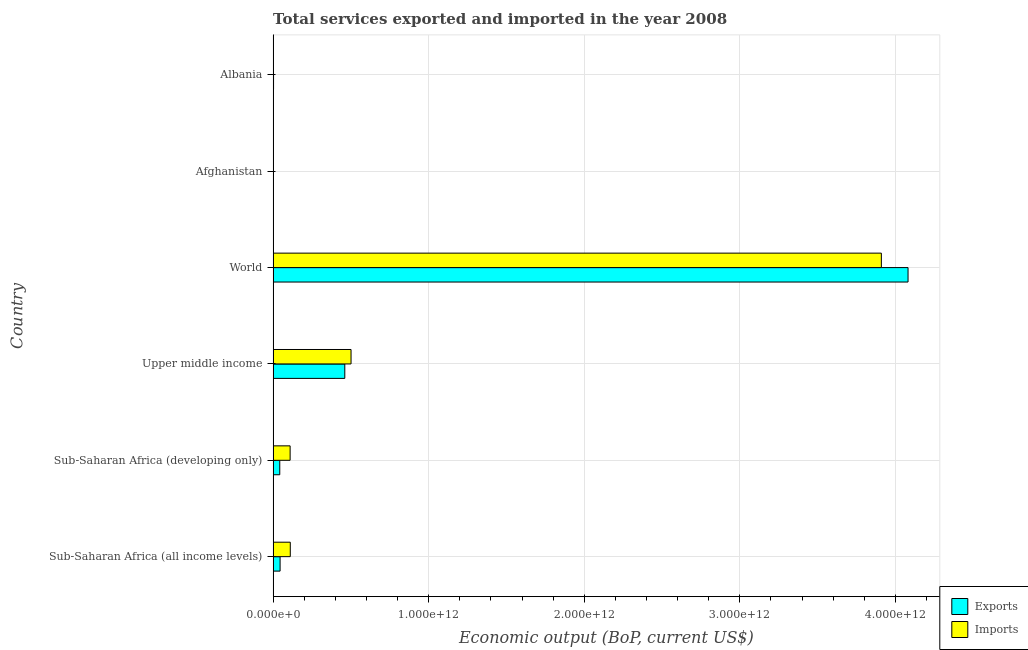Are the number of bars per tick equal to the number of legend labels?
Give a very brief answer. Yes. How many bars are there on the 6th tick from the top?
Provide a succinct answer. 2. In how many cases, is the number of bars for a given country not equal to the number of legend labels?
Provide a succinct answer. 0. What is the amount of service imports in World?
Offer a very short reply. 3.91e+12. Across all countries, what is the maximum amount of service imports?
Ensure brevity in your answer.  3.91e+12. Across all countries, what is the minimum amount of service imports?
Your response must be concise. 5.71e+08. In which country was the amount of service imports minimum?
Provide a succinct answer. Afghanistan. What is the total amount of service exports in the graph?
Your answer should be compact. 4.63e+12. What is the difference between the amount of service exports in Afghanistan and that in Sub-Saharan Africa (developing only)?
Your answer should be very brief. -4.15e+1. What is the difference between the amount of service exports in World and the amount of service imports in Albania?
Your response must be concise. 4.08e+12. What is the average amount of service imports per country?
Your answer should be very brief. 7.72e+11. What is the difference between the amount of service imports and amount of service exports in Upper middle income?
Your response must be concise. 4.02e+1. In how many countries, is the amount of service imports greater than 3200000000000 US$?
Offer a terse response. 1. What is the ratio of the amount of service imports in Sub-Saharan Africa (developing only) to that in Upper middle income?
Your answer should be very brief. 0.22. Is the amount of service imports in Albania less than that in Sub-Saharan Africa (developing only)?
Make the answer very short. Yes. What is the difference between the highest and the second highest amount of service exports?
Make the answer very short. 3.62e+12. What is the difference between the highest and the lowest amount of service imports?
Offer a terse response. 3.91e+12. Is the sum of the amount of service imports in Afghanistan and Sub-Saharan Africa (all income levels) greater than the maximum amount of service exports across all countries?
Ensure brevity in your answer.  No. What does the 1st bar from the top in World represents?
Offer a terse response. Imports. What does the 2nd bar from the bottom in Sub-Saharan Africa (all income levels) represents?
Offer a very short reply. Imports. Are all the bars in the graph horizontal?
Ensure brevity in your answer.  Yes. What is the difference between two consecutive major ticks on the X-axis?
Provide a succinct answer. 1.00e+12. Does the graph contain grids?
Make the answer very short. Yes. Where does the legend appear in the graph?
Offer a terse response. Bottom right. How are the legend labels stacked?
Provide a short and direct response. Vertical. What is the title of the graph?
Your answer should be very brief. Total services exported and imported in the year 2008. Does "Forest land" appear as one of the legend labels in the graph?
Provide a succinct answer. No. What is the label or title of the X-axis?
Keep it short and to the point. Economic output (BoP, current US$). What is the label or title of the Y-axis?
Your answer should be very brief. Country. What is the Economic output (BoP, current US$) in Exports in Sub-Saharan Africa (all income levels)?
Provide a short and direct response. 4.48e+1. What is the Economic output (BoP, current US$) of Imports in Sub-Saharan Africa (all income levels)?
Ensure brevity in your answer.  1.10e+11. What is the Economic output (BoP, current US$) of Exports in Sub-Saharan Africa (developing only)?
Provide a succinct answer. 4.27e+1. What is the Economic output (BoP, current US$) in Imports in Sub-Saharan Africa (developing only)?
Offer a very short reply. 1.09e+11. What is the Economic output (BoP, current US$) in Exports in Upper middle income?
Make the answer very short. 4.61e+11. What is the Economic output (BoP, current US$) of Imports in Upper middle income?
Your response must be concise. 5.01e+11. What is the Economic output (BoP, current US$) of Exports in World?
Provide a short and direct response. 4.08e+12. What is the Economic output (BoP, current US$) of Imports in World?
Your answer should be compact. 3.91e+12. What is the Economic output (BoP, current US$) in Exports in Afghanistan?
Offer a very short reply. 1.22e+09. What is the Economic output (BoP, current US$) in Imports in Afghanistan?
Offer a very short reply. 5.71e+08. What is the Economic output (BoP, current US$) in Exports in Albania?
Offer a very short reply. 2.73e+09. What is the Economic output (BoP, current US$) of Imports in Albania?
Provide a succinct answer. 2.37e+09. Across all countries, what is the maximum Economic output (BoP, current US$) of Exports?
Your response must be concise. 4.08e+12. Across all countries, what is the maximum Economic output (BoP, current US$) of Imports?
Provide a succinct answer. 3.91e+12. Across all countries, what is the minimum Economic output (BoP, current US$) of Exports?
Offer a terse response. 1.22e+09. Across all countries, what is the minimum Economic output (BoP, current US$) in Imports?
Provide a short and direct response. 5.71e+08. What is the total Economic output (BoP, current US$) of Exports in the graph?
Your response must be concise. 4.63e+12. What is the total Economic output (BoP, current US$) in Imports in the graph?
Your answer should be very brief. 4.63e+12. What is the difference between the Economic output (BoP, current US$) of Exports in Sub-Saharan Africa (all income levels) and that in Sub-Saharan Africa (developing only)?
Offer a terse response. 2.07e+09. What is the difference between the Economic output (BoP, current US$) of Imports in Sub-Saharan Africa (all income levels) and that in Sub-Saharan Africa (developing only)?
Keep it short and to the point. 1.06e+09. What is the difference between the Economic output (BoP, current US$) in Exports in Sub-Saharan Africa (all income levels) and that in Upper middle income?
Offer a very short reply. -4.16e+11. What is the difference between the Economic output (BoP, current US$) in Imports in Sub-Saharan Africa (all income levels) and that in Upper middle income?
Your answer should be compact. -3.91e+11. What is the difference between the Economic output (BoP, current US$) in Exports in Sub-Saharan Africa (all income levels) and that in World?
Your answer should be very brief. -4.04e+12. What is the difference between the Economic output (BoP, current US$) of Imports in Sub-Saharan Africa (all income levels) and that in World?
Ensure brevity in your answer.  -3.80e+12. What is the difference between the Economic output (BoP, current US$) in Exports in Sub-Saharan Africa (all income levels) and that in Afghanistan?
Offer a terse response. 4.36e+1. What is the difference between the Economic output (BoP, current US$) in Imports in Sub-Saharan Africa (all income levels) and that in Afghanistan?
Your answer should be compact. 1.10e+11. What is the difference between the Economic output (BoP, current US$) in Exports in Sub-Saharan Africa (all income levels) and that in Albania?
Your answer should be compact. 4.21e+1. What is the difference between the Economic output (BoP, current US$) of Imports in Sub-Saharan Africa (all income levels) and that in Albania?
Ensure brevity in your answer.  1.08e+11. What is the difference between the Economic output (BoP, current US$) of Exports in Sub-Saharan Africa (developing only) and that in Upper middle income?
Provide a succinct answer. -4.18e+11. What is the difference between the Economic output (BoP, current US$) in Imports in Sub-Saharan Africa (developing only) and that in Upper middle income?
Keep it short and to the point. -3.92e+11. What is the difference between the Economic output (BoP, current US$) in Exports in Sub-Saharan Africa (developing only) and that in World?
Ensure brevity in your answer.  -4.04e+12. What is the difference between the Economic output (BoP, current US$) in Imports in Sub-Saharan Africa (developing only) and that in World?
Offer a terse response. -3.80e+12. What is the difference between the Economic output (BoP, current US$) in Exports in Sub-Saharan Africa (developing only) and that in Afghanistan?
Offer a terse response. 4.15e+1. What is the difference between the Economic output (BoP, current US$) in Imports in Sub-Saharan Africa (developing only) and that in Afghanistan?
Offer a terse response. 1.09e+11. What is the difference between the Economic output (BoP, current US$) of Exports in Sub-Saharan Africa (developing only) and that in Albania?
Your response must be concise. 4.00e+1. What is the difference between the Economic output (BoP, current US$) of Imports in Sub-Saharan Africa (developing only) and that in Albania?
Your answer should be very brief. 1.07e+11. What is the difference between the Economic output (BoP, current US$) of Exports in Upper middle income and that in World?
Your answer should be very brief. -3.62e+12. What is the difference between the Economic output (BoP, current US$) of Imports in Upper middle income and that in World?
Ensure brevity in your answer.  -3.41e+12. What is the difference between the Economic output (BoP, current US$) in Exports in Upper middle income and that in Afghanistan?
Provide a succinct answer. 4.59e+11. What is the difference between the Economic output (BoP, current US$) of Imports in Upper middle income and that in Afghanistan?
Provide a short and direct response. 5.00e+11. What is the difference between the Economic output (BoP, current US$) in Exports in Upper middle income and that in Albania?
Give a very brief answer. 4.58e+11. What is the difference between the Economic output (BoP, current US$) of Imports in Upper middle income and that in Albania?
Offer a very short reply. 4.99e+11. What is the difference between the Economic output (BoP, current US$) of Exports in World and that in Afghanistan?
Provide a succinct answer. 4.08e+12. What is the difference between the Economic output (BoP, current US$) in Imports in World and that in Afghanistan?
Make the answer very short. 3.91e+12. What is the difference between the Economic output (BoP, current US$) of Exports in World and that in Albania?
Your answer should be very brief. 4.08e+12. What is the difference between the Economic output (BoP, current US$) in Imports in World and that in Albania?
Keep it short and to the point. 3.91e+12. What is the difference between the Economic output (BoP, current US$) of Exports in Afghanistan and that in Albania?
Offer a very short reply. -1.51e+09. What is the difference between the Economic output (BoP, current US$) in Imports in Afghanistan and that in Albania?
Ensure brevity in your answer.  -1.80e+09. What is the difference between the Economic output (BoP, current US$) of Exports in Sub-Saharan Africa (all income levels) and the Economic output (BoP, current US$) of Imports in Sub-Saharan Africa (developing only)?
Your response must be concise. -6.44e+1. What is the difference between the Economic output (BoP, current US$) of Exports in Sub-Saharan Africa (all income levels) and the Economic output (BoP, current US$) of Imports in Upper middle income?
Your answer should be compact. -4.56e+11. What is the difference between the Economic output (BoP, current US$) in Exports in Sub-Saharan Africa (all income levels) and the Economic output (BoP, current US$) in Imports in World?
Keep it short and to the point. -3.86e+12. What is the difference between the Economic output (BoP, current US$) of Exports in Sub-Saharan Africa (all income levels) and the Economic output (BoP, current US$) of Imports in Afghanistan?
Your answer should be compact. 4.42e+1. What is the difference between the Economic output (BoP, current US$) in Exports in Sub-Saharan Africa (all income levels) and the Economic output (BoP, current US$) in Imports in Albania?
Give a very brief answer. 4.24e+1. What is the difference between the Economic output (BoP, current US$) in Exports in Sub-Saharan Africa (developing only) and the Economic output (BoP, current US$) in Imports in Upper middle income?
Provide a short and direct response. -4.58e+11. What is the difference between the Economic output (BoP, current US$) in Exports in Sub-Saharan Africa (developing only) and the Economic output (BoP, current US$) in Imports in World?
Keep it short and to the point. -3.87e+12. What is the difference between the Economic output (BoP, current US$) in Exports in Sub-Saharan Africa (developing only) and the Economic output (BoP, current US$) in Imports in Afghanistan?
Provide a short and direct response. 4.22e+1. What is the difference between the Economic output (BoP, current US$) of Exports in Sub-Saharan Africa (developing only) and the Economic output (BoP, current US$) of Imports in Albania?
Offer a very short reply. 4.04e+1. What is the difference between the Economic output (BoP, current US$) of Exports in Upper middle income and the Economic output (BoP, current US$) of Imports in World?
Provide a short and direct response. -3.45e+12. What is the difference between the Economic output (BoP, current US$) in Exports in Upper middle income and the Economic output (BoP, current US$) in Imports in Afghanistan?
Keep it short and to the point. 4.60e+11. What is the difference between the Economic output (BoP, current US$) of Exports in Upper middle income and the Economic output (BoP, current US$) of Imports in Albania?
Offer a very short reply. 4.58e+11. What is the difference between the Economic output (BoP, current US$) of Exports in World and the Economic output (BoP, current US$) of Imports in Afghanistan?
Your answer should be very brief. 4.08e+12. What is the difference between the Economic output (BoP, current US$) of Exports in World and the Economic output (BoP, current US$) of Imports in Albania?
Keep it short and to the point. 4.08e+12. What is the difference between the Economic output (BoP, current US$) of Exports in Afghanistan and the Economic output (BoP, current US$) of Imports in Albania?
Make the answer very short. -1.15e+09. What is the average Economic output (BoP, current US$) in Exports per country?
Provide a short and direct response. 7.72e+11. What is the average Economic output (BoP, current US$) in Imports per country?
Your response must be concise. 7.72e+11. What is the difference between the Economic output (BoP, current US$) of Exports and Economic output (BoP, current US$) of Imports in Sub-Saharan Africa (all income levels)?
Ensure brevity in your answer.  -6.55e+1. What is the difference between the Economic output (BoP, current US$) in Exports and Economic output (BoP, current US$) in Imports in Sub-Saharan Africa (developing only)?
Give a very brief answer. -6.65e+1. What is the difference between the Economic output (BoP, current US$) in Exports and Economic output (BoP, current US$) in Imports in Upper middle income?
Your answer should be compact. -4.02e+1. What is the difference between the Economic output (BoP, current US$) in Exports and Economic output (BoP, current US$) in Imports in World?
Ensure brevity in your answer.  1.72e+11. What is the difference between the Economic output (BoP, current US$) in Exports and Economic output (BoP, current US$) in Imports in Afghanistan?
Provide a short and direct response. 6.49e+08. What is the difference between the Economic output (BoP, current US$) of Exports and Economic output (BoP, current US$) of Imports in Albania?
Your answer should be very brief. 3.60e+08. What is the ratio of the Economic output (BoP, current US$) of Exports in Sub-Saharan Africa (all income levels) to that in Sub-Saharan Africa (developing only)?
Your answer should be compact. 1.05. What is the ratio of the Economic output (BoP, current US$) in Imports in Sub-Saharan Africa (all income levels) to that in Sub-Saharan Africa (developing only)?
Give a very brief answer. 1.01. What is the ratio of the Economic output (BoP, current US$) in Exports in Sub-Saharan Africa (all income levels) to that in Upper middle income?
Your answer should be very brief. 0.1. What is the ratio of the Economic output (BoP, current US$) of Imports in Sub-Saharan Africa (all income levels) to that in Upper middle income?
Make the answer very short. 0.22. What is the ratio of the Economic output (BoP, current US$) of Exports in Sub-Saharan Africa (all income levels) to that in World?
Offer a terse response. 0.01. What is the ratio of the Economic output (BoP, current US$) in Imports in Sub-Saharan Africa (all income levels) to that in World?
Provide a short and direct response. 0.03. What is the ratio of the Economic output (BoP, current US$) of Exports in Sub-Saharan Africa (all income levels) to that in Afghanistan?
Provide a succinct answer. 36.72. What is the ratio of the Economic output (BoP, current US$) in Imports in Sub-Saharan Africa (all income levels) to that in Afghanistan?
Your response must be concise. 193.05. What is the ratio of the Economic output (BoP, current US$) in Exports in Sub-Saharan Africa (all income levels) to that in Albania?
Offer a terse response. 16.4. What is the ratio of the Economic output (BoP, current US$) in Imports in Sub-Saharan Africa (all income levels) to that in Albania?
Keep it short and to the point. 46.5. What is the ratio of the Economic output (BoP, current US$) in Exports in Sub-Saharan Africa (developing only) to that in Upper middle income?
Provide a short and direct response. 0.09. What is the ratio of the Economic output (BoP, current US$) of Imports in Sub-Saharan Africa (developing only) to that in Upper middle income?
Your answer should be very brief. 0.22. What is the ratio of the Economic output (BoP, current US$) in Exports in Sub-Saharan Africa (developing only) to that in World?
Offer a very short reply. 0.01. What is the ratio of the Economic output (BoP, current US$) of Imports in Sub-Saharan Africa (developing only) to that in World?
Offer a very short reply. 0.03. What is the ratio of the Economic output (BoP, current US$) of Exports in Sub-Saharan Africa (developing only) to that in Afghanistan?
Your answer should be very brief. 35.02. What is the ratio of the Economic output (BoP, current US$) in Imports in Sub-Saharan Africa (developing only) to that in Afghanistan?
Your response must be concise. 191.2. What is the ratio of the Economic output (BoP, current US$) of Exports in Sub-Saharan Africa (developing only) to that in Albania?
Offer a very short reply. 15.64. What is the ratio of the Economic output (BoP, current US$) of Imports in Sub-Saharan Africa (developing only) to that in Albania?
Provide a short and direct response. 46.06. What is the ratio of the Economic output (BoP, current US$) in Exports in Upper middle income to that in World?
Provide a short and direct response. 0.11. What is the ratio of the Economic output (BoP, current US$) in Imports in Upper middle income to that in World?
Your response must be concise. 0.13. What is the ratio of the Economic output (BoP, current US$) of Exports in Upper middle income to that in Afghanistan?
Make the answer very short. 377.55. What is the ratio of the Economic output (BoP, current US$) in Imports in Upper middle income to that in Afghanistan?
Ensure brevity in your answer.  876.61. What is the ratio of the Economic output (BoP, current US$) of Exports in Upper middle income to that in Albania?
Keep it short and to the point. 168.63. What is the ratio of the Economic output (BoP, current US$) in Imports in Upper middle income to that in Albania?
Offer a terse response. 211.15. What is the ratio of the Economic output (BoP, current US$) of Exports in World to that in Afghanistan?
Offer a very short reply. 3344.42. What is the ratio of the Economic output (BoP, current US$) in Imports in World to that in Afghanistan?
Offer a terse response. 6841.98. What is the ratio of the Economic output (BoP, current US$) in Exports in World to that in Albania?
Provide a succinct answer. 1493.73. What is the ratio of the Economic output (BoP, current US$) in Imports in World to that in Albania?
Your answer should be compact. 1648.07. What is the ratio of the Economic output (BoP, current US$) of Exports in Afghanistan to that in Albania?
Ensure brevity in your answer.  0.45. What is the ratio of the Economic output (BoP, current US$) of Imports in Afghanistan to that in Albania?
Keep it short and to the point. 0.24. What is the difference between the highest and the second highest Economic output (BoP, current US$) of Exports?
Give a very brief answer. 3.62e+12. What is the difference between the highest and the second highest Economic output (BoP, current US$) of Imports?
Offer a terse response. 3.41e+12. What is the difference between the highest and the lowest Economic output (BoP, current US$) of Exports?
Your response must be concise. 4.08e+12. What is the difference between the highest and the lowest Economic output (BoP, current US$) in Imports?
Ensure brevity in your answer.  3.91e+12. 